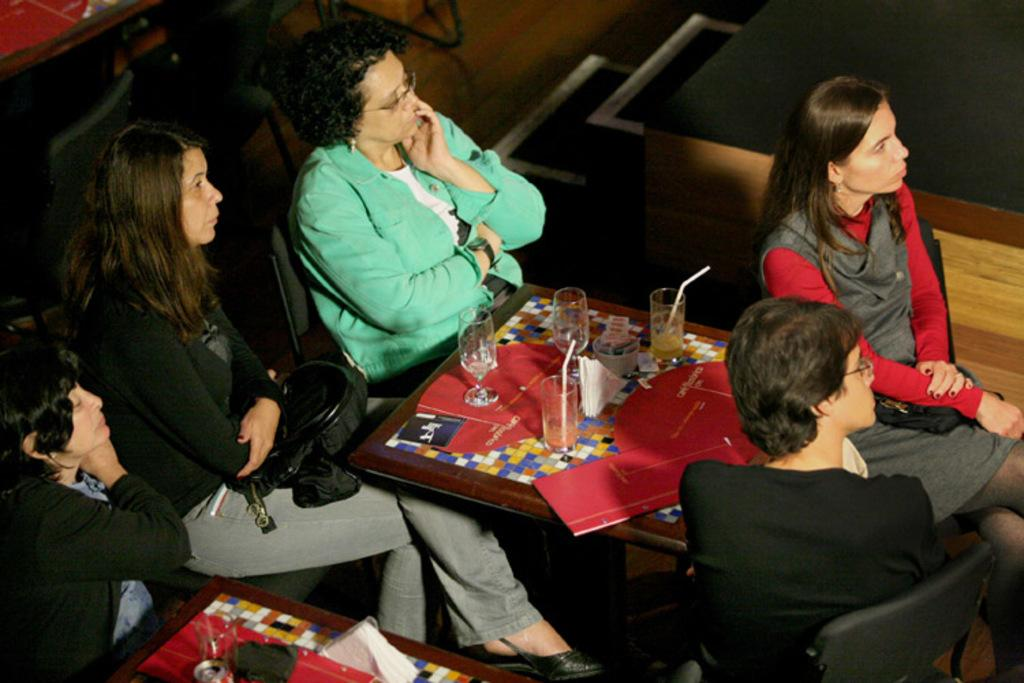What can be seen in the image? There is a group of women in the image. What are the women doing in the image? The women are sitting on chairs in the image. How are the chairs arranged in the image? The chairs are arranged around a table in the image. What might the women be watching in the image? The women are watching something in the image. What objects can be seen on the table in the image? There are glasses placed on the table in the image. What type of shade is being provided by the women's throats in the image? There is no mention of shade or throats in the image; the focus is on the women sitting around a table and watching something. 